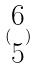Convert formula to latex. <formula><loc_0><loc_0><loc_500><loc_500>( \begin{matrix} 6 \\ 5 \end{matrix} )</formula> 